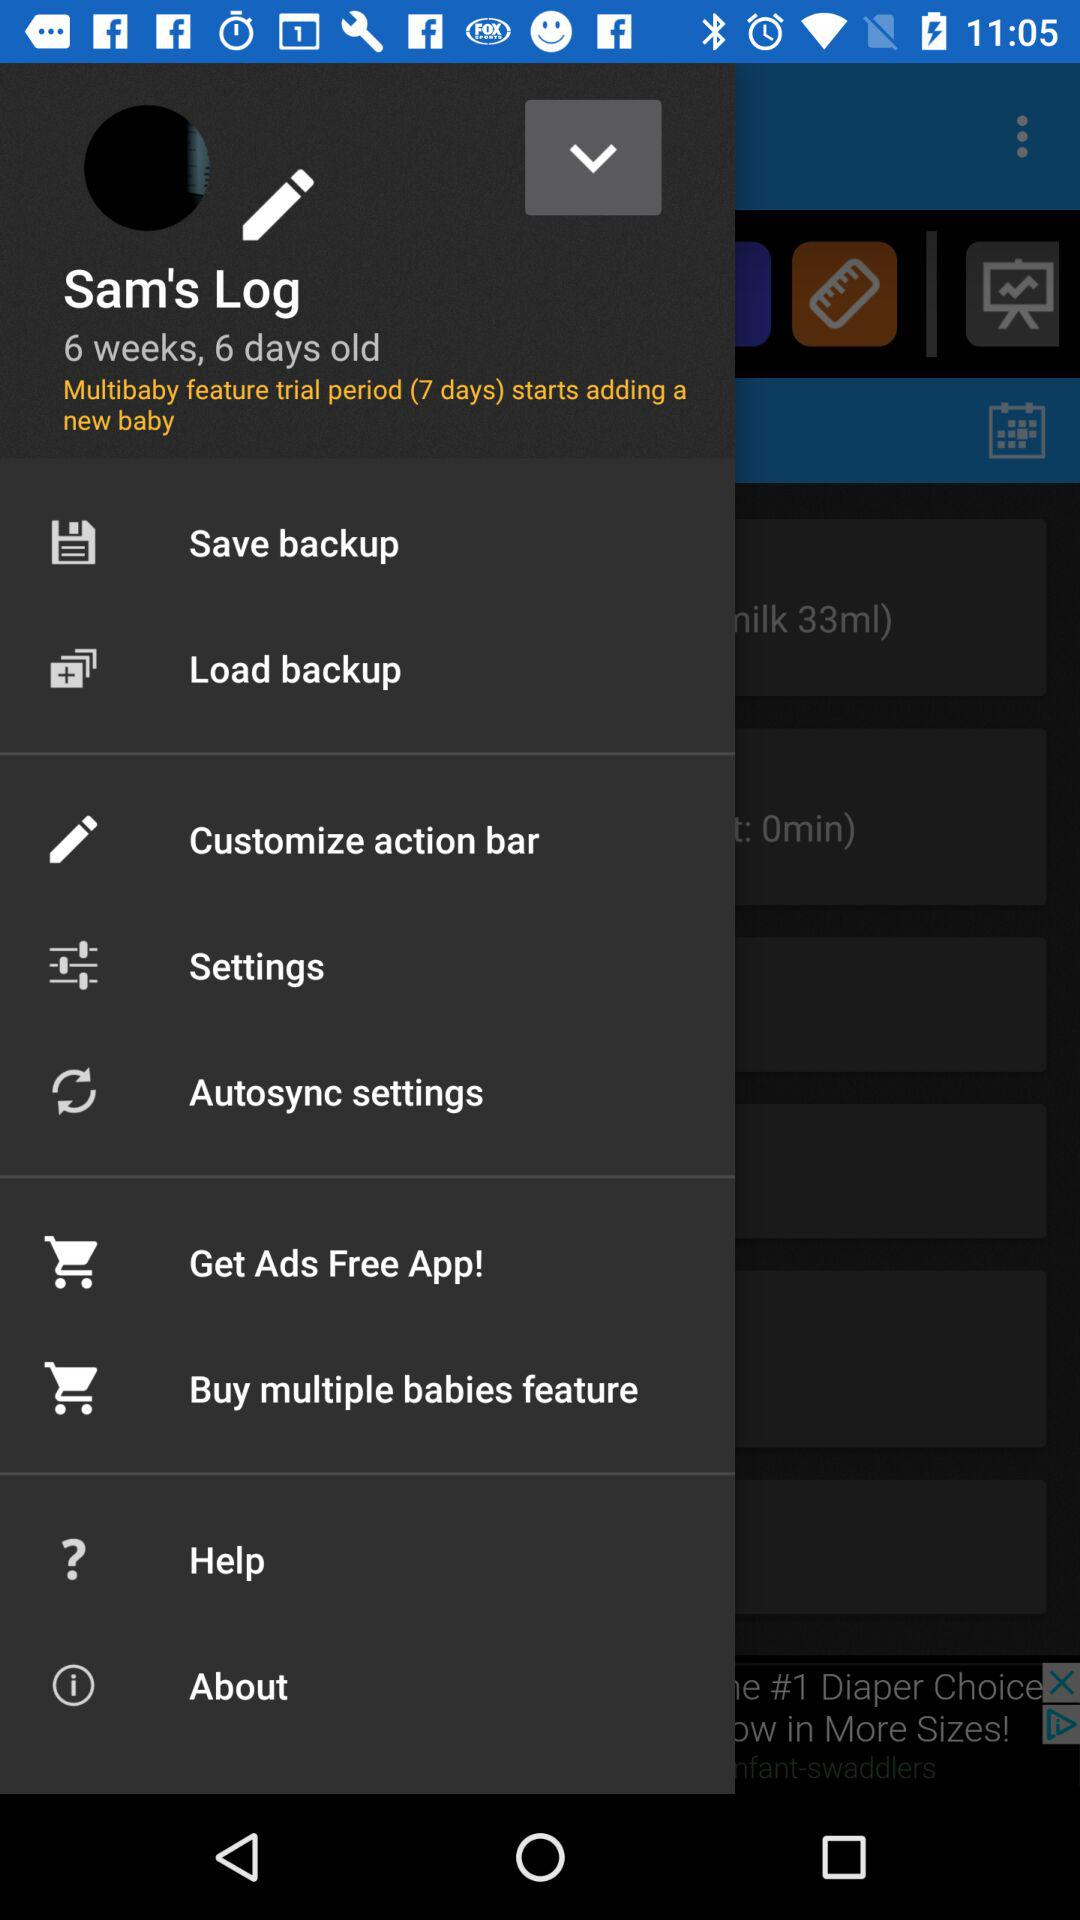What is the username? The username is "Sam's Log". 